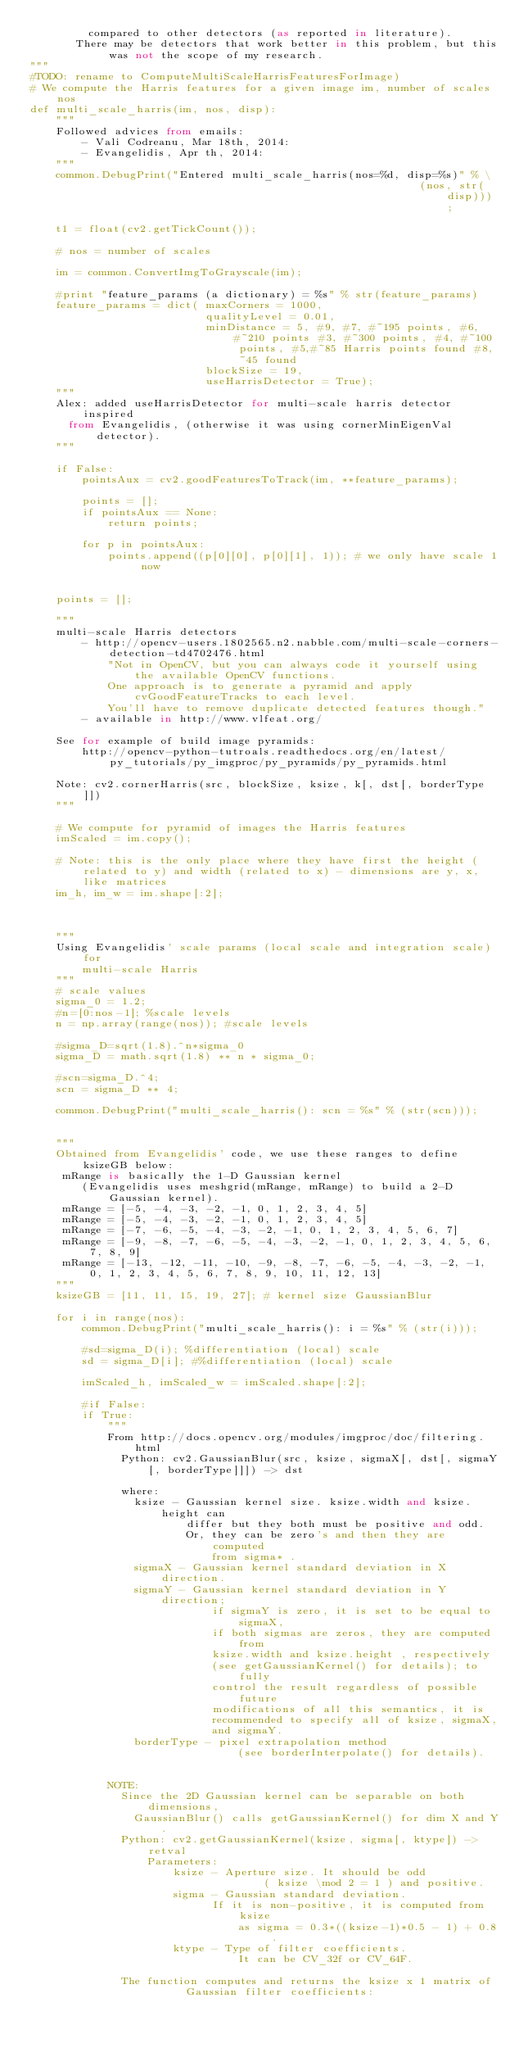Convert code to text. <code><loc_0><loc_0><loc_500><loc_500><_Python_>         compared to other detectors (as reported in literature).
       There may be detectors that work better in this problem, but this was not the scope of my research.
"""
#TODO: rename to ComputeMultiScaleHarrisFeaturesForImage)
# We compute the Harris features for a given image im, number of scales nos
def multi_scale_harris(im, nos, disp):
    """
    Followed advices from emails:
        - Vali Codreanu, Mar 18th, 2014:
        - Evangelidis, Apr th, 2014:
    """
    common.DebugPrint("Entered multi_scale_harris(nos=%d, disp=%s)" % \
                                                            (nos, str(disp)));

    t1 = float(cv2.getTickCount());

    # nos = number of scales

    im = common.ConvertImgToGrayscale(im);

    #print "feature_params (a dictionary) = %s" % str(feature_params)
    feature_params = dict( maxCorners = 1000,
                           qualityLevel = 0.01,
                           minDistance = 5, #9, #7, #~195 points, #6, #~210 points #3, #~300 points, #4, #~100 points, #5,#~85 Harris points found #8, ~45 found
                           blockSize = 19,
                           useHarrisDetector = True);
    """
    Alex: added useHarrisDetector for multi-scale harris detector inspired
      from Evangelidis, (otherwise it was using cornerMinEigenVal detector).
    """

    if False:
        pointsAux = cv2.goodFeaturesToTrack(im, **feature_params);

        points = [];
        if pointsAux == None:
            return points;

        for p in pointsAux:
            points.append((p[0][0], p[0][1], 1)); # we only have scale 1 now


    points = [];

    """
    multi-scale Harris detectors
        - http://opencv-users.1802565.n2.nabble.com/multi-scale-corners-detection-td4702476.html
            "Not in OpenCV, but you can always code it yourself using the available OpenCV functions.
            One approach is to generate a pyramid and apply cvGoodFeatureTracks to each level.
            You'll have to remove duplicate detected features though."
        - available in http://www.vlfeat.org/

    See for example of build image pyramids:
        http://opencv-python-tutroals.readthedocs.org/en/latest/py_tutorials/py_imgproc/py_pyramids/py_pyramids.html

    Note: cv2.cornerHarris(src, blockSize, ksize, k[, dst[, borderType ]])
    """

    # We compute for pyramid of images the Harris features
    imScaled = im.copy();

    # Note: this is the only place where they have first the height (related to y) and width (related to x) - dimensions are y, x, like matrices
    im_h, im_w = im.shape[:2];



    """
    Using Evangelidis' scale params (local scale and integration scale) for
        multi-scale Harris
    """
    # scale values
    sigma_0 = 1.2;
    #n=[0:nos-1]; %scale levels
    n = np.array(range(nos)); #scale levels

    #sigma_D=sqrt(1.8).^n*sigma_0
    sigma_D = math.sqrt(1.8) ** n * sigma_0;

    #scn=sigma_D.^4;
    scn = sigma_D ** 4;

    common.DebugPrint("multi_scale_harris(): scn = %s" % (str(scn)));


    """
    Obtained from Evangelidis' code, we use these ranges to define ksizeGB below:
     mRange is basically the 1-D Gaussian kernel
        (Evangelidis uses meshgrid(mRange, mRange) to build a 2-D Gaussian kernel).
     mRange = [-5, -4, -3, -2, -1, 0, 1, 2, 3, 4, 5]
     mRange = [-5, -4, -3, -2, -1, 0, 1, 2, 3, 4, 5]
     mRange = [-7, -6, -5, -4, -3, -2, -1, 0, 1, 2, 3, 4, 5, 6, 7]
     mRange = [-9, -8, -7, -6, -5, -4, -3, -2, -1, 0, 1, 2, 3, 4, 5, 6, 7, 8, 9]
     mRange = [-13, -12, -11, -10, -9, -8, -7, -6, -5, -4, -3, -2, -1, 0, 1, 2, 3, 4, 5, 6, 7, 8, 9, 10, 11, 12, 13]
    """
    ksizeGB = [11, 11, 15, 19, 27]; # kernel size GaussianBlur

    for i in range(nos):
        common.DebugPrint("multi_scale_harris(): i = %s" % (str(i)));

        #sd=sigma_D(i); %differentiation (local) scale
        sd = sigma_D[i]; #%differentiation (local) scale

        imScaled_h, imScaled_w = imScaled.shape[:2];

        #if False:
        if True:
            """
            From http://docs.opencv.org/modules/imgproc/doc/filtering.html
              Python: cv2.GaussianBlur(src, ksize, sigmaX[, dst[, sigmaY[, borderType]]]) -> dst

              where:
                ksize - Gaussian kernel size. ksize.width and ksize.height can
                        differ but they both must be positive and odd.
                        Or, they can be zero's and then they are computed
                            from sigma* .
                sigmaX - Gaussian kernel standard deviation in X direction.
                sigmaY - Gaussian kernel standard deviation in Y direction;
                            if sigmaY is zero, it is set to be equal to sigmaX,
                            if both sigmas are zeros, they are computed from
                            ksize.width and ksize.height , respectively
                            (see getGaussianKernel() for details); to fully
                            control the result regardless of possible future
                            modifications of all this semantics, it is
                            recommended to specify all of ksize, sigmaX,
                            and sigmaY.
                borderType - pixel extrapolation method
                                (see borderInterpolate() for details).


            NOTE:
              Since the 2D Gaussian kernel can be separable on both dimensions,
                GaussianBlur() calls getGaussianKernel() for dim X and Y.
              Python: cv2.getGaussianKernel(ksize, sigma[, ktype]) -> retval
                  Parameters:
                      ksize - Aperture size. It should be odd
                                    ( ksize \mod 2 = 1 ) and positive.
                      sigma - Gaussian standard deviation.
                            If it is non-positive, it is computed from ksize
                                as sigma = 0.3*((ksize-1)*0.5 - 1) + 0.8 .
                      ktype - Type of filter coefficients.
                                It can be CV_32f or CV_64F.

              The function computes and returns the ksize x 1 matrix of
                        Gaussian filter coefficients:
</code> 